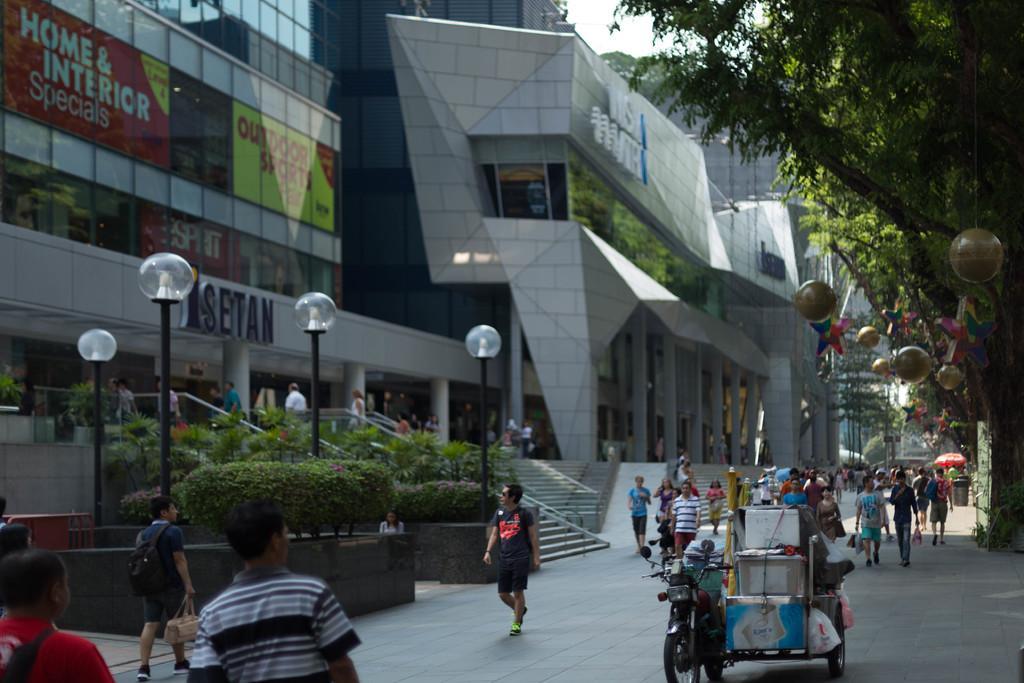Can you describe this image briefly? This is an outside view. At the bottom, I can see a crowd of people walking on the road and also there is a vehicle. Beside the road there are few poles. In the background there are many buildings and trees. On the left side there are few plants. At the top of the image I can see the sky. 